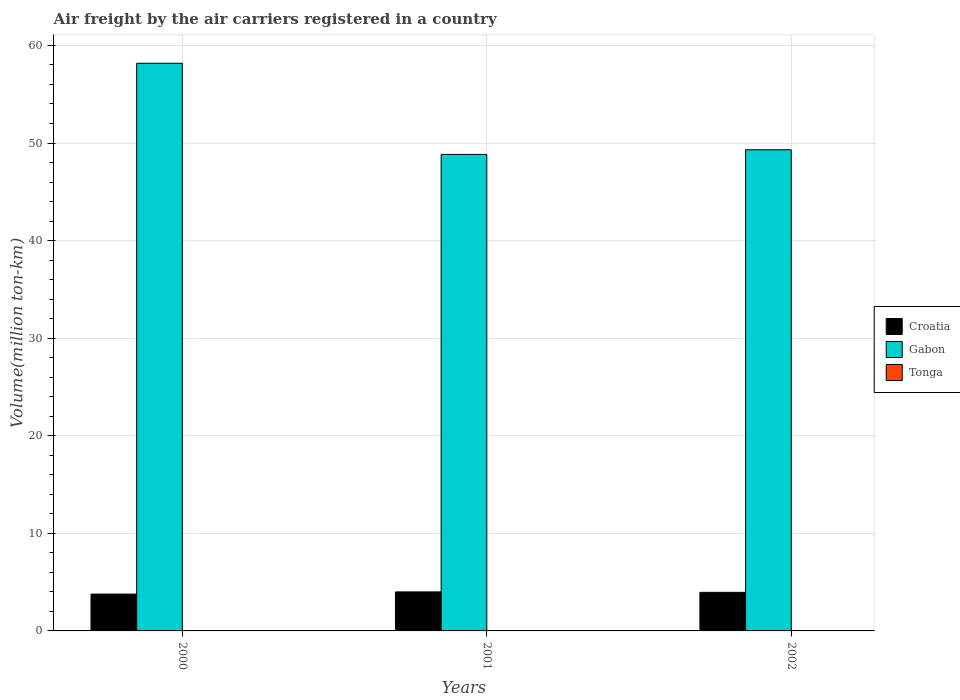How many groups of bars are there?
Offer a very short reply. 3. Are the number of bars per tick equal to the number of legend labels?
Give a very brief answer. Yes. Are the number of bars on each tick of the X-axis equal?
Ensure brevity in your answer.  Yes. What is the volume of the air carriers in Gabon in 2001?
Offer a very short reply. 48.83. Across all years, what is the maximum volume of the air carriers in Tonga?
Provide a short and direct response. 0.02. Across all years, what is the minimum volume of the air carriers in Tonga?
Keep it short and to the point. 0.02. In which year was the volume of the air carriers in Croatia maximum?
Make the answer very short. 2001. In which year was the volume of the air carriers in Tonga minimum?
Ensure brevity in your answer.  2000. What is the total volume of the air carriers in Croatia in the graph?
Offer a very short reply. 11.72. What is the difference between the volume of the air carriers in Tonga in 2000 and that in 2002?
Your answer should be compact. -0.01. What is the difference between the volume of the air carriers in Gabon in 2001 and the volume of the air carriers in Croatia in 2002?
Give a very brief answer. 44.88. What is the average volume of the air carriers in Tonga per year?
Ensure brevity in your answer.  0.02. In the year 2002, what is the difference between the volume of the air carriers in Gabon and volume of the air carriers in Croatia?
Make the answer very short. 45.36. In how many years, is the volume of the air carriers in Croatia greater than 54 million ton-km?
Ensure brevity in your answer.  0. What is the ratio of the volume of the air carriers in Gabon in 2000 to that in 2002?
Your answer should be very brief. 1.18. What is the difference between the highest and the second highest volume of the air carriers in Gabon?
Provide a short and direct response. 8.86. What is the difference between the highest and the lowest volume of the air carriers in Croatia?
Make the answer very short. 0.22. Is the sum of the volume of the air carriers in Tonga in 2000 and 2002 greater than the maximum volume of the air carriers in Gabon across all years?
Your response must be concise. No. What does the 2nd bar from the left in 2002 represents?
Your answer should be compact. Gabon. What does the 3rd bar from the right in 2001 represents?
Provide a succinct answer. Croatia. How many years are there in the graph?
Ensure brevity in your answer.  3. What is the difference between two consecutive major ticks on the Y-axis?
Your answer should be very brief. 10. Does the graph contain any zero values?
Your answer should be compact. No. Where does the legend appear in the graph?
Provide a short and direct response. Center right. How are the legend labels stacked?
Provide a succinct answer. Vertical. What is the title of the graph?
Make the answer very short. Air freight by the air carriers registered in a country. Does "Moldova" appear as one of the legend labels in the graph?
Your answer should be very brief. No. What is the label or title of the X-axis?
Provide a succinct answer. Years. What is the label or title of the Y-axis?
Keep it short and to the point. Volume(million ton-km). What is the Volume(million ton-km) of Croatia in 2000?
Ensure brevity in your answer.  3.77. What is the Volume(million ton-km) of Gabon in 2000?
Offer a very short reply. 58.17. What is the Volume(million ton-km) of Tonga in 2000?
Offer a very short reply. 0.02. What is the Volume(million ton-km) in Croatia in 2001?
Your response must be concise. 4. What is the Volume(million ton-km) of Gabon in 2001?
Keep it short and to the point. 48.83. What is the Volume(million ton-km) of Tonga in 2001?
Your answer should be compact. 0.02. What is the Volume(million ton-km) in Croatia in 2002?
Give a very brief answer. 3.95. What is the Volume(million ton-km) of Gabon in 2002?
Your answer should be very brief. 49.31. What is the Volume(million ton-km) in Tonga in 2002?
Your response must be concise. 0.02. Across all years, what is the maximum Volume(million ton-km) of Croatia?
Keep it short and to the point. 4. Across all years, what is the maximum Volume(million ton-km) in Gabon?
Your answer should be compact. 58.17. Across all years, what is the maximum Volume(million ton-km) in Tonga?
Provide a short and direct response. 0.02. Across all years, what is the minimum Volume(million ton-km) of Croatia?
Offer a very short reply. 3.77. Across all years, what is the minimum Volume(million ton-km) in Gabon?
Your answer should be compact. 48.83. Across all years, what is the minimum Volume(million ton-km) in Tonga?
Provide a succinct answer. 0.02. What is the total Volume(million ton-km) in Croatia in the graph?
Offer a very short reply. 11.72. What is the total Volume(million ton-km) in Gabon in the graph?
Your answer should be compact. 156.32. What is the total Volume(million ton-km) of Tonga in the graph?
Your response must be concise. 0.06. What is the difference between the Volume(million ton-km) of Croatia in 2000 and that in 2001?
Your answer should be very brief. -0.22. What is the difference between the Volume(million ton-km) of Gabon in 2000 and that in 2001?
Give a very brief answer. 9.34. What is the difference between the Volume(million ton-km) of Tonga in 2000 and that in 2001?
Ensure brevity in your answer.  -0. What is the difference between the Volume(million ton-km) in Croatia in 2000 and that in 2002?
Your answer should be very brief. -0.18. What is the difference between the Volume(million ton-km) in Gabon in 2000 and that in 2002?
Give a very brief answer. 8.86. What is the difference between the Volume(million ton-km) of Tonga in 2000 and that in 2002?
Ensure brevity in your answer.  -0.01. What is the difference between the Volume(million ton-km) of Croatia in 2001 and that in 2002?
Keep it short and to the point. 0.04. What is the difference between the Volume(million ton-km) of Gabon in 2001 and that in 2002?
Offer a very short reply. -0.48. What is the difference between the Volume(million ton-km) of Tonga in 2001 and that in 2002?
Offer a very short reply. -0. What is the difference between the Volume(million ton-km) of Croatia in 2000 and the Volume(million ton-km) of Gabon in 2001?
Give a very brief answer. -45.06. What is the difference between the Volume(million ton-km) of Croatia in 2000 and the Volume(million ton-km) of Tonga in 2001?
Keep it short and to the point. 3.75. What is the difference between the Volume(million ton-km) of Gabon in 2000 and the Volume(million ton-km) of Tonga in 2001?
Provide a short and direct response. 58.15. What is the difference between the Volume(million ton-km) of Croatia in 2000 and the Volume(million ton-km) of Gabon in 2002?
Make the answer very short. -45.53. What is the difference between the Volume(million ton-km) in Croatia in 2000 and the Volume(million ton-km) in Tonga in 2002?
Your answer should be very brief. 3.75. What is the difference between the Volume(million ton-km) in Gabon in 2000 and the Volume(million ton-km) in Tonga in 2002?
Provide a succinct answer. 58.15. What is the difference between the Volume(million ton-km) in Croatia in 2001 and the Volume(million ton-km) in Gabon in 2002?
Ensure brevity in your answer.  -45.31. What is the difference between the Volume(million ton-km) in Croatia in 2001 and the Volume(million ton-km) in Tonga in 2002?
Provide a short and direct response. 3.97. What is the difference between the Volume(million ton-km) of Gabon in 2001 and the Volume(million ton-km) of Tonga in 2002?
Offer a terse response. 48.81. What is the average Volume(million ton-km) of Croatia per year?
Offer a terse response. 3.91. What is the average Volume(million ton-km) in Gabon per year?
Ensure brevity in your answer.  52.11. What is the average Volume(million ton-km) in Tonga per year?
Ensure brevity in your answer.  0.02. In the year 2000, what is the difference between the Volume(million ton-km) of Croatia and Volume(million ton-km) of Gabon?
Make the answer very short. -54.4. In the year 2000, what is the difference between the Volume(million ton-km) of Croatia and Volume(million ton-km) of Tonga?
Provide a succinct answer. 3.76. In the year 2000, what is the difference between the Volume(million ton-km) in Gabon and Volume(million ton-km) in Tonga?
Make the answer very short. 58.16. In the year 2001, what is the difference between the Volume(million ton-km) of Croatia and Volume(million ton-km) of Gabon?
Keep it short and to the point. -44.84. In the year 2001, what is the difference between the Volume(million ton-km) in Croatia and Volume(million ton-km) in Tonga?
Make the answer very short. 3.98. In the year 2001, what is the difference between the Volume(million ton-km) of Gabon and Volume(million ton-km) of Tonga?
Ensure brevity in your answer.  48.81. In the year 2002, what is the difference between the Volume(million ton-km) of Croatia and Volume(million ton-km) of Gabon?
Give a very brief answer. -45.36. In the year 2002, what is the difference between the Volume(million ton-km) of Croatia and Volume(million ton-km) of Tonga?
Your response must be concise. 3.93. In the year 2002, what is the difference between the Volume(million ton-km) in Gabon and Volume(million ton-km) in Tonga?
Your response must be concise. 49.29. What is the ratio of the Volume(million ton-km) of Croatia in 2000 to that in 2001?
Ensure brevity in your answer.  0.94. What is the ratio of the Volume(million ton-km) in Gabon in 2000 to that in 2001?
Your answer should be very brief. 1.19. What is the ratio of the Volume(million ton-km) of Tonga in 2000 to that in 2001?
Ensure brevity in your answer.  0.81. What is the ratio of the Volume(million ton-km) in Croatia in 2000 to that in 2002?
Provide a short and direct response. 0.95. What is the ratio of the Volume(million ton-km) in Gabon in 2000 to that in 2002?
Give a very brief answer. 1.18. What is the ratio of the Volume(million ton-km) of Tonga in 2000 to that in 2002?
Your response must be concise. 0.71. What is the ratio of the Volume(million ton-km) in Croatia in 2001 to that in 2002?
Keep it short and to the point. 1.01. What is the ratio of the Volume(million ton-km) of Gabon in 2001 to that in 2002?
Ensure brevity in your answer.  0.99. What is the ratio of the Volume(million ton-km) of Tonga in 2001 to that in 2002?
Your answer should be compact. 0.88. What is the difference between the highest and the second highest Volume(million ton-km) in Croatia?
Offer a terse response. 0.04. What is the difference between the highest and the second highest Volume(million ton-km) in Gabon?
Provide a succinct answer. 8.86. What is the difference between the highest and the second highest Volume(million ton-km) in Tonga?
Offer a terse response. 0. What is the difference between the highest and the lowest Volume(million ton-km) in Croatia?
Keep it short and to the point. 0.22. What is the difference between the highest and the lowest Volume(million ton-km) of Gabon?
Offer a very short reply. 9.34. What is the difference between the highest and the lowest Volume(million ton-km) in Tonga?
Make the answer very short. 0.01. 